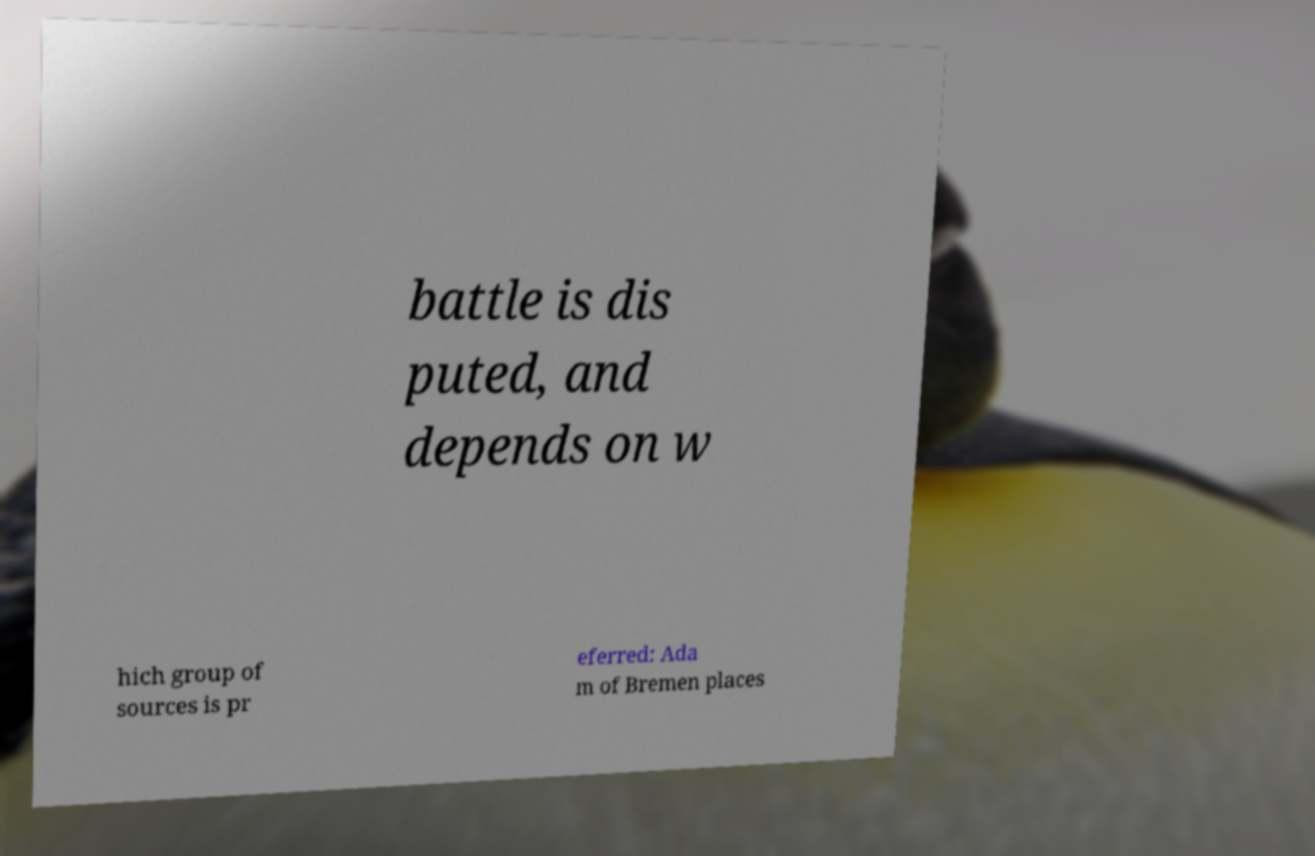Please read and relay the text visible in this image. What does it say? battle is dis puted, and depends on w hich group of sources is pr eferred: Ada m of Bremen places 